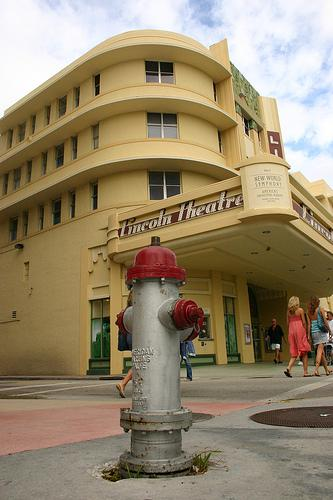Question: what color is the building?
Choices:
A. Yellow.
B. White.
C. Brown.
D. Beige.
Answer with the letter. Answer: A Question: what are the people doing?
Choices:
A. Swimming.
B. Eating.
C. Riding bicycles.
D. Walking down the sidewalk.
Answer with the letter. Answer: D Question: why is there a fire hydrant on the sidewalk?
Choices:
A. A landmark.
B. It is there in case of a fire.
C. For block parties.
D. For hot summer days.
Answer with the letter. Answer: B Question: when will the fire hydrant be used?
Choices:
A. When a building catches on fire near the hydrant.
B. When there is a block party.
C. When it's summertime.
D. When firefighters arrive.
Answer with the letter. Answer: A Question: who is walking in this photo?
Choices:
A. Two boys.
B. Two little girls.
C. A group of friends.
D. Men and women.
Answer with the letter. Answer: D Question: where is this photo taken?
Choices:
A. The zoo.
B. A baseball game.
C. On a sidewalk in front of a building.
D. A park.
Answer with the letter. Answer: C 